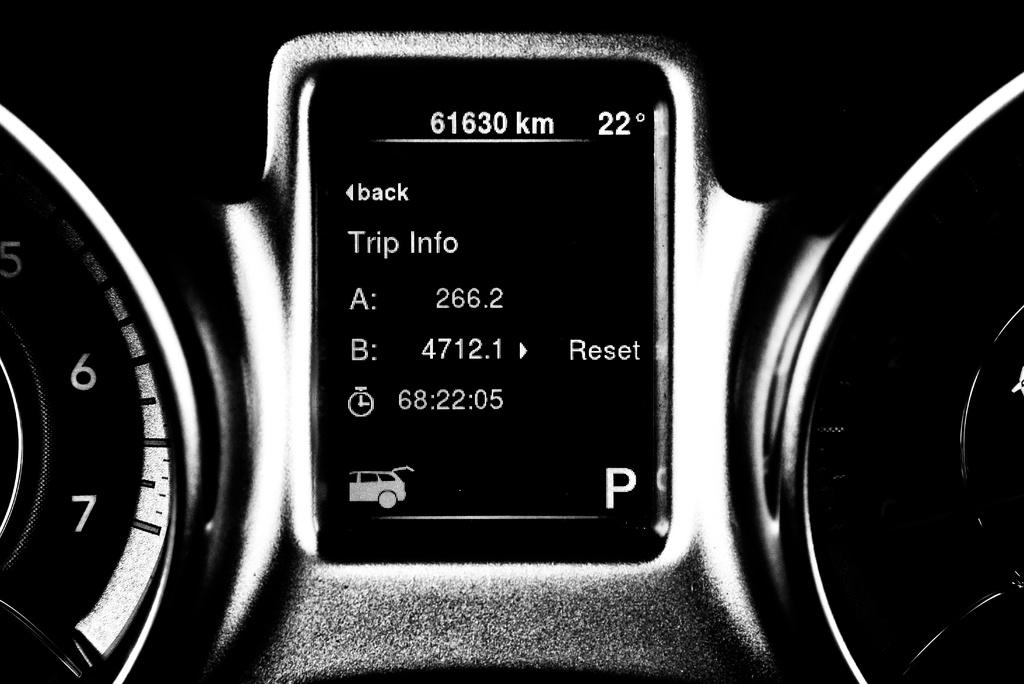What is the color scheme of the image? The image is black and white. What is the main subject of the image? The main subject of the image is the speedometers of a vehicle. What is located in the center of the image? There is a screen in the center of the image. What information is displayed on the screen? There are numbers, text, and alphabets on the screen. What type of image can be seen on the screen? There is an image of a car on the screen. How many flowers are present in the image? There are no flowers present in the image. How many boys can be seen in the image? There are no boys present in the image. 